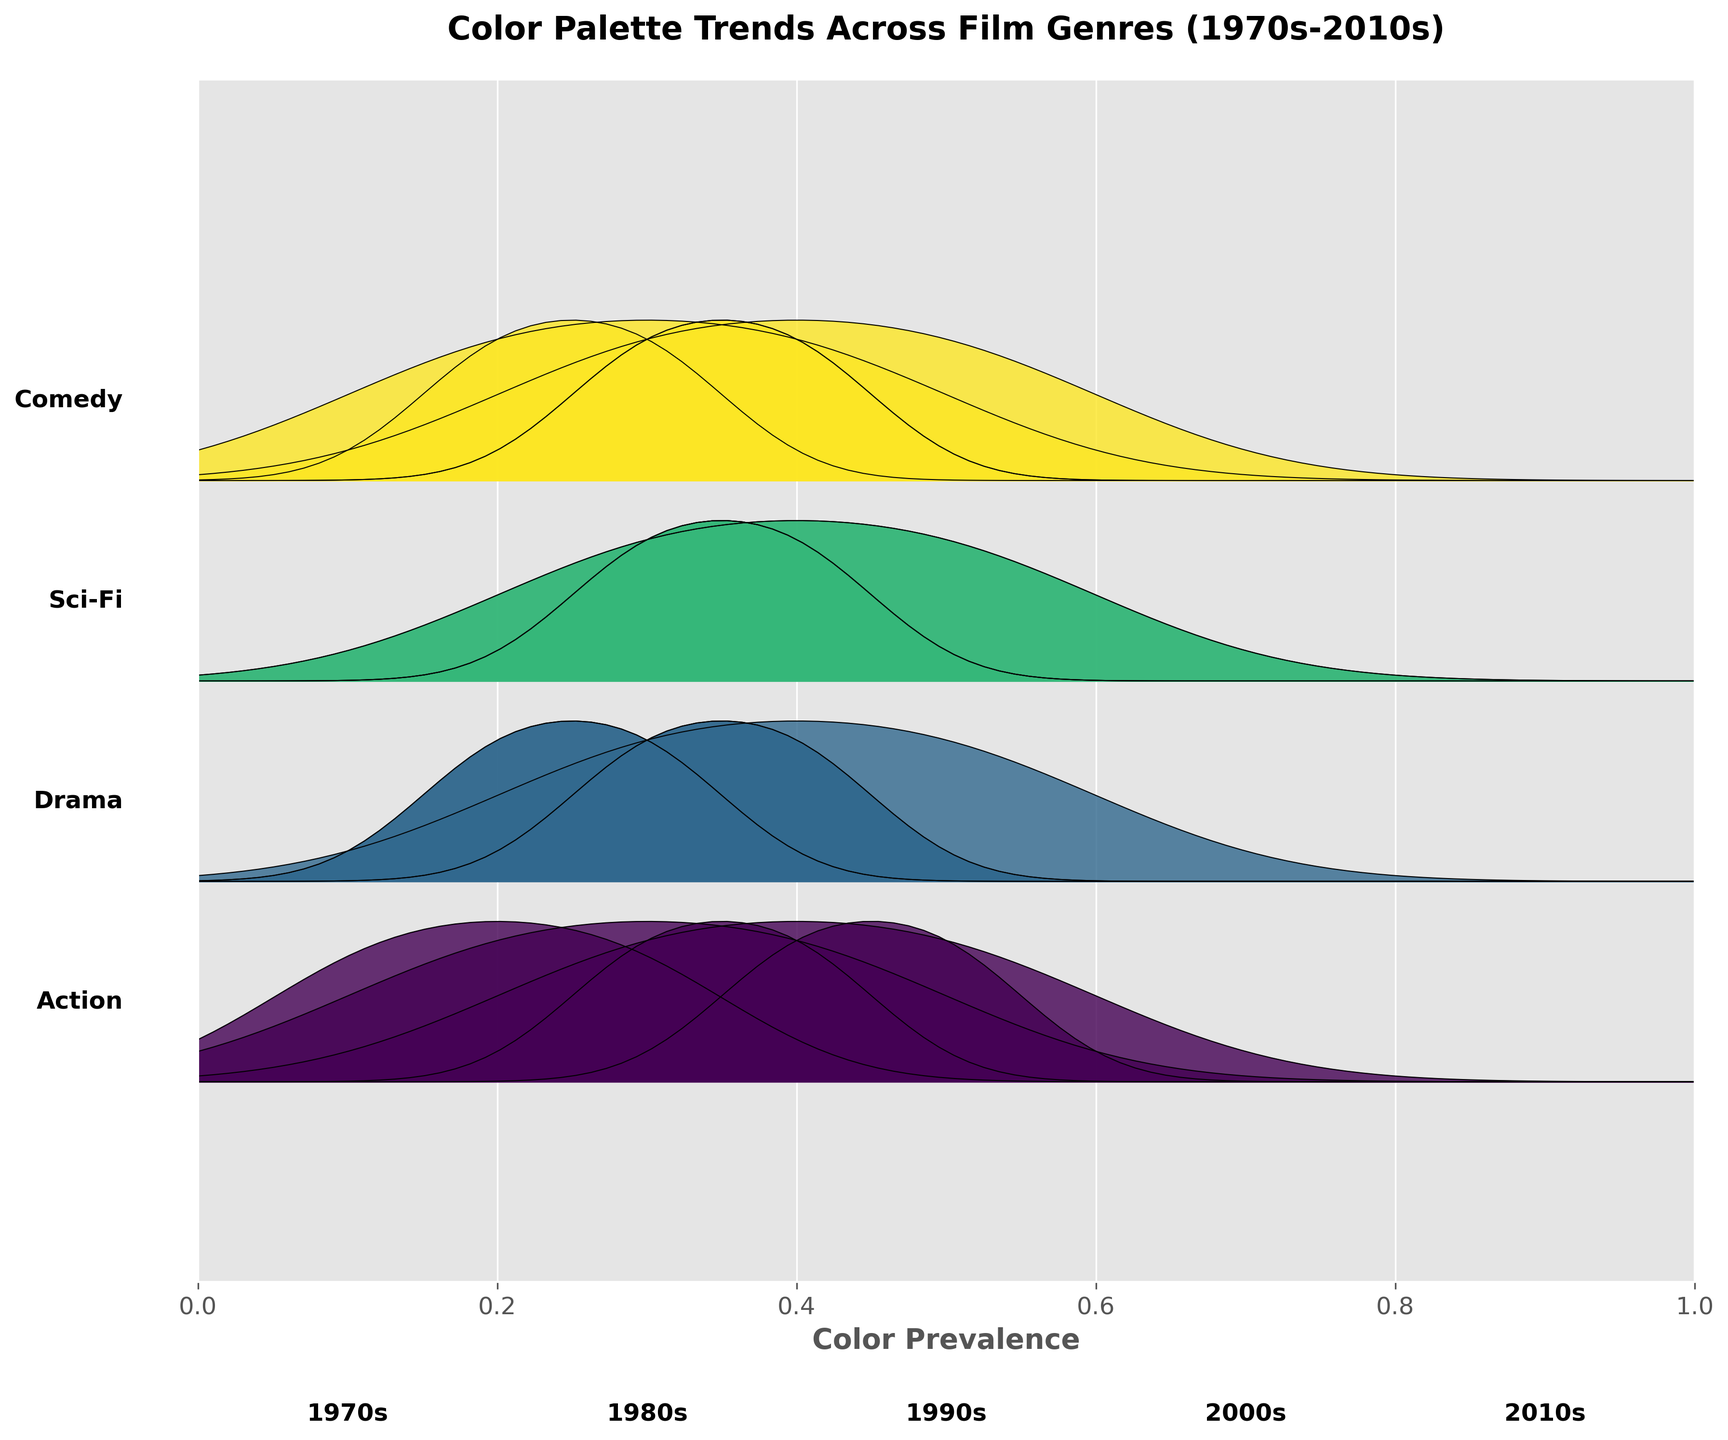What is the title of the plot? The title is located at the top of the plot and provides an overview of what the plot represents.
Answer: "Color Palette Trends Across Film Genres (1970s-2010s)" How many unique genres are represented in the plot? We can count how many unique genre labels are present along the y-axis of the plot.
Answer: 4 Which decade shows the highest prevalence of 'Blue' color in the Action genre? Look at the Action genre ridgeline plot. Identify the decade where 'Blue' has the highest prevalence based on the plot's filled area.
Answer: 2010s What color was most prevalent in the Drama genre during the 2010s? Examine the ridgeline plot for the Drama genre in the 2010s and determine which color has the highest filled area.
Answer: Muted Brown Compare the prevalence of 'Orange' color between the 1980s Comedy and the 1980s Action genres. Which genre had a higher prevalence? Identify the areas filled for 'Orange' in both Comedy and Action genres in the 1980s. Compare their areas to determine which is larger.
Answer: Action Which genre used 'Gray' color predominantly in the 2000s? Check the 2000s ridgeline plots of each genre and identify which genre has a prominent peak for 'Gray'.
Answer: Drama How did the prevalence of 'Red' in the Action genre change from the 1970s to the 2010s? Track the 'Red' color's ridgeline within the Action genre across the decades from 1970s to 2010s and describe the trend.
Answer: Decreased What color trends can be observed in Sci-Fi from the 1980s to the 2000s? Examine the dominant colors in the Sci-Fi genre ridgelines from the 1980s to the 2000s. Note the shifts in color dominance over the decades.
Answer: Shift from ‘Neon Blue’ and ‘Neon Pink’ to ‘Blue’ Which genre exhibited the most colorful diversity in the 1980s? Compare the ridgeline plots of all genres in the 1980s and identify which genre depicts the widest range of colors.
Answer: Sci-Fi 